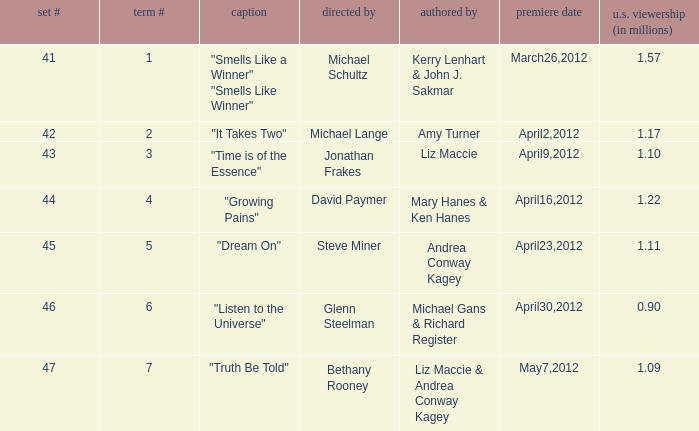How many millions of viewers did the episode written by Andrea Conway Kagey? 1.11. 